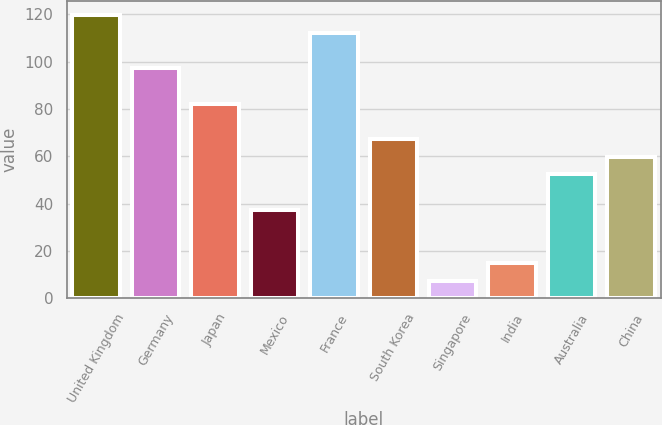Convert chart to OTSL. <chart><loc_0><loc_0><loc_500><loc_500><bar_chart><fcel>United Kingdom<fcel>Germany<fcel>Japan<fcel>Mexico<fcel>France<fcel>South Korea<fcel>Singapore<fcel>India<fcel>Australia<fcel>China<nl><fcel>119.78<fcel>97.34<fcel>82.38<fcel>37.5<fcel>112.3<fcel>67.42<fcel>7.58<fcel>15.06<fcel>52.46<fcel>59.94<nl></chart> 